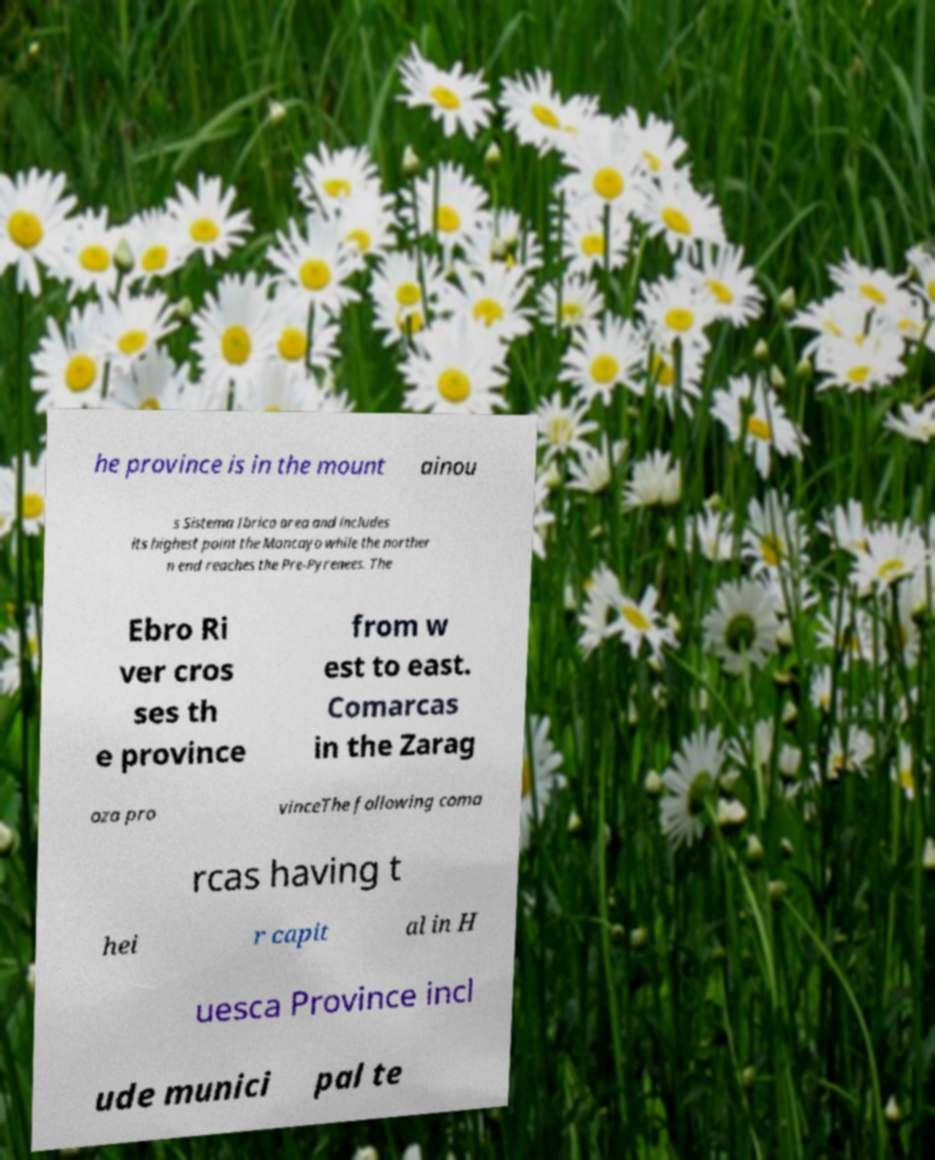Please read and relay the text visible in this image. What does it say? he province is in the mount ainou s Sistema Ibrico area and includes its highest point the Moncayo while the norther n end reaches the Pre-Pyrenees. The Ebro Ri ver cros ses th e province from w est to east. Comarcas in the Zarag oza pro vinceThe following coma rcas having t hei r capit al in H uesca Province incl ude munici pal te 